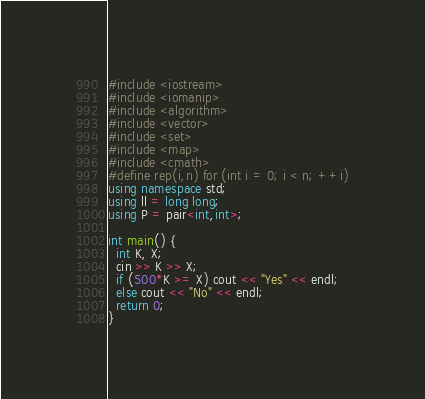Convert code to text. <code><loc_0><loc_0><loc_500><loc_500><_C++_>#include <iostream>
#include <iomanip>
#include <algorithm>
#include <vector>
#include <set>
#include <map>
#include <cmath>
#define rep(i,n) for (int i = 0; i < n; ++i)
using namespace std;
using ll = long long;
using P = pair<int,int>;

int main() {
  int K, X;
  cin >> K >> X;
  if (500*K >= X) cout << "Yes" << endl;
  else cout << "No" << endl;
  return 0;
}</code> 